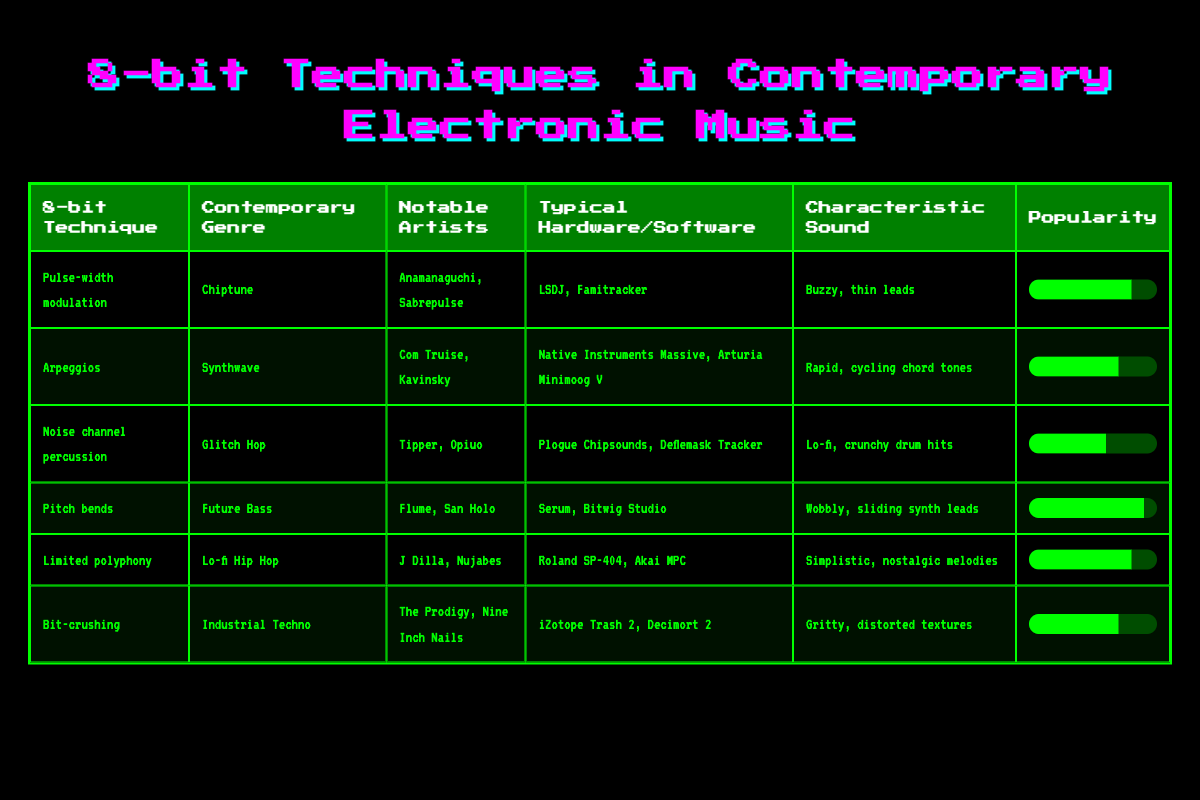What contemporary genre uses pitch bends? The table lists "Pitch bends" under the column "8-bit Technique." In the corresponding row, the "Contemporary Genre" is given as "Future Bass."
Answer: Future Bass Which notable artists are associated with the Glitch Hop genre? Referring to the row for "Noise channel percussion," which is listed under the "8-bit Technique." The "Contemporary Genre" in that row is "Glitch Hop," and the "Notable Artists" listed are "Tipper, Opiuo."
Answer: Tipper, Opiuo What characteristic sound is associated with the technique of pulse-width modulation? Looking at the row for "Pulse-width modulation," the "Characteristic Sound" provided is "Buzzy, thin leads." This directly answers the question about what sound relates to that technique.
Answer: Buzzy, thin leads Are arpeggios used more frequently in Synthwave than in Industrial Techno? By checking the popularity ratings, "Arpeggios" in Synthwave has a popularity of 7, while "Bit-crushing" in Industrial Techno has a popularity rating of 7. Since both popularity scores are equal, it indicates that arpeggios are not used more frequently.
Answer: No What is the average popularity score for the 8-bit techniques listed? First, we sum all the popularity scores: (8 + 7 + 6 + 9 + 8 + 7) = 45. Since there are 6 techniques, we calculate the average as 45/6, which results in 7.5.
Answer: 7.5 Which contemporary genres demonstrate a characteristic sound of 'lo-fi, crunchy drum hits'? The table shows that the "Noise channel percussion" technique corresponds to the "Contemporary Genre" of "Glitch Hop" and that this row's "Characteristic Sound" is "Lo-fi, crunchy drum hits."
Answer: Glitch Hop Is the characteristic sound of pitch bends described as "wobbly, sliding synth leads"? In the row for "Pitch bends," the "Characteristic Sound" is indeed stated to be "Wobbly, sliding synth leads." Therefore, this statement is true.
Answer: Yes What is the relationship between the technique of limited polyphony and lo-fi hip hop's notable artists? The "Limited polyphony" technique is listed under the "Contemporary Genre" of "Lo-fi Hip Hop," where the "Notable Artists" provided are "J Dilla, Nujabes," establishing a direct connection.
Answer: J Dilla, Nujabes 